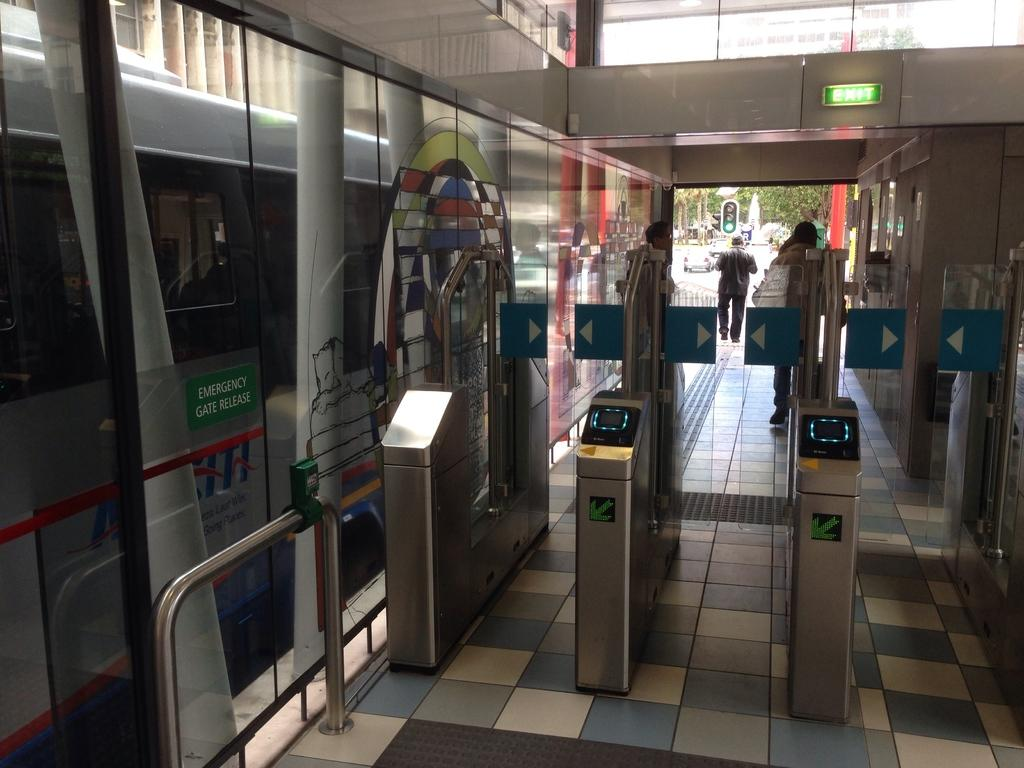<image>
Present a compact description of the photo's key features. Subway Terminal of a subway train that is passing through, the words on the train say Emergency Gate Release. 